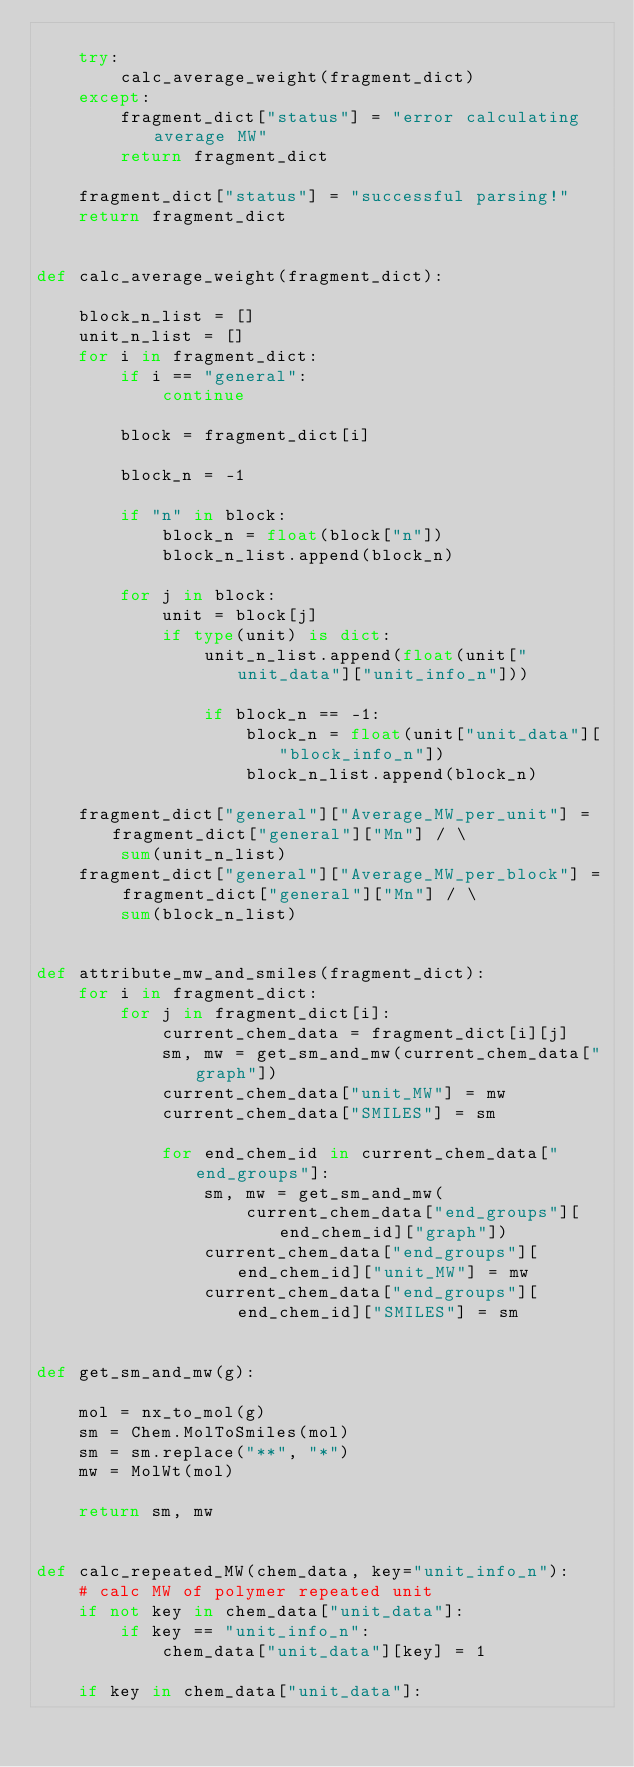<code> <loc_0><loc_0><loc_500><loc_500><_Python_>
    try:
        calc_average_weight(fragment_dict)
    except:
        fragment_dict["status"] = "error calculating average MW"
        return fragment_dict

    fragment_dict["status"] = "successful parsing!"
    return fragment_dict


def calc_average_weight(fragment_dict):

    block_n_list = []
    unit_n_list = []
    for i in fragment_dict:
        if i == "general":
            continue

        block = fragment_dict[i]

        block_n = -1

        if "n" in block:
            block_n = float(block["n"])
            block_n_list.append(block_n)

        for j in block:
            unit = block[j]
            if type(unit) is dict:
                unit_n_list.append(float(unit["unit_data"]["unit_info_n"]))

                if block_n == -1:
                    block_n = float(unit["unit_data"]["block_info_n"])
                    block_n_list.append(block_n)

    fragment_dict["general"]["Average_MW_per_unit"] = fragment_dict["general"]["Mn"] / \
        sum(unit_n_list)
    fragment_dict["general"]["Average_MW_per_block"] = fragment_dict["general"]["Mn"] / \
        sum(block_n_list)


def attribute_mw_and_smiles(fragment_dict):
    for i in fragment_dict:
        for j in fragment_dict[i]:
            current_chem_data = fragment_dict[i][j]
            sm, mw = get_sm_and_mw(current_chem_data["graph"])
            current_chem_data["unit_MW"] = mw
            current_chem_data["SMILES"] = sm

            for end_chem_id in current_chem_data["end_groups"]:
                sm, mw = get_sm_and_mw(
                    current_chem_data["end_groups"][end_chem_id]["graph"])
                current_chem_data["end_groups"][end_chem_id]["unit_MW"] = mw
                current_chem_data["end_groups"][end_chem_id]["SMILES"] = sm


def get_sm_and_mw(g):

    mol = nx_to_mol(g)
    sm = Chem.MolToSmiles(mol)
    sm = sm.replace("**", "*")
    mw = MolWt(mol)

    return sm, mw


def calc_repeated_MW(chem_data, key="unit_info_n"):
    # calc MW of polymer repeated unit
    if not key in chem_data["unit_data"]:
        if key == "unit_info_n":
            chem_data["unit_data"][key] = 1

    if key in chem_data["unit_data"]:</code> 